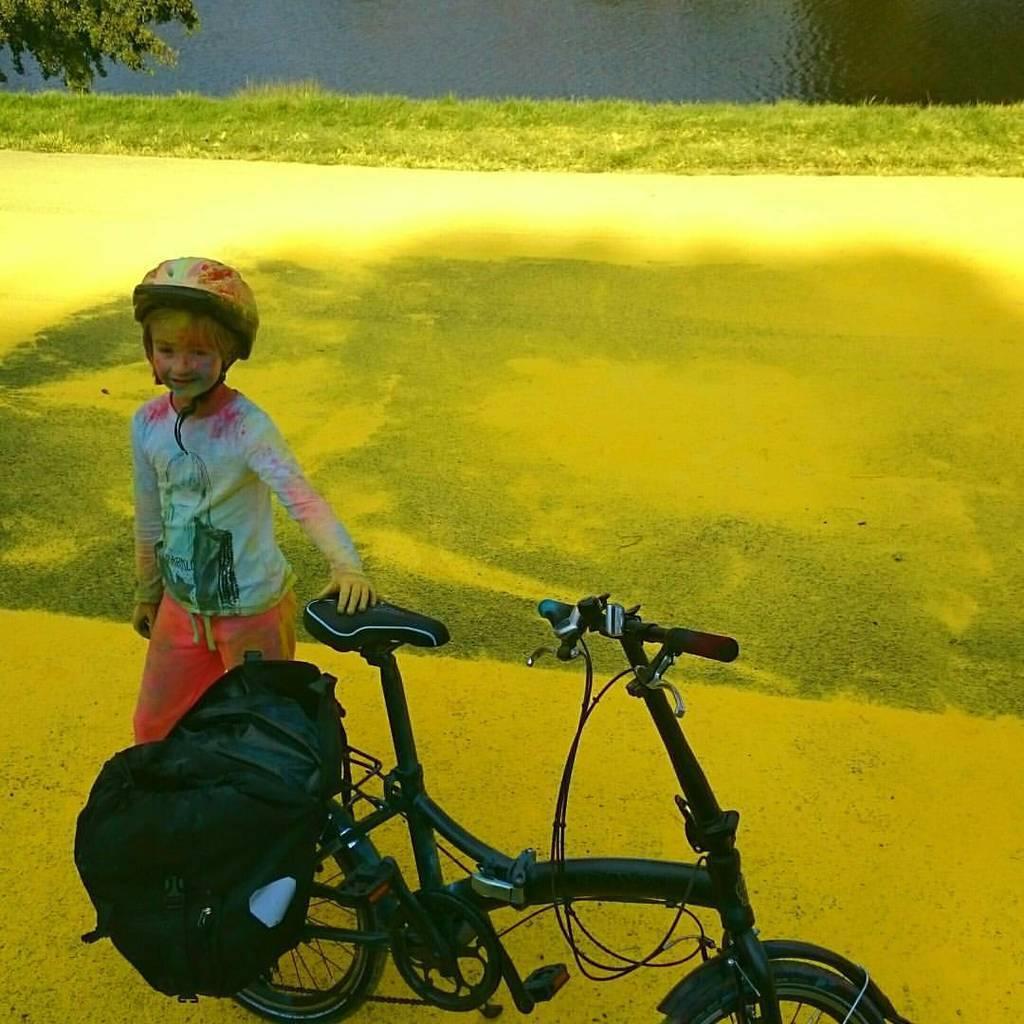Could you give a brief overview of what you see in this image? In this image we can see a kid wearing a helmet and standing on the road, there is a cycle in front of the kid and a bag on the cycle, in the background there is a tree, grass and the water. 